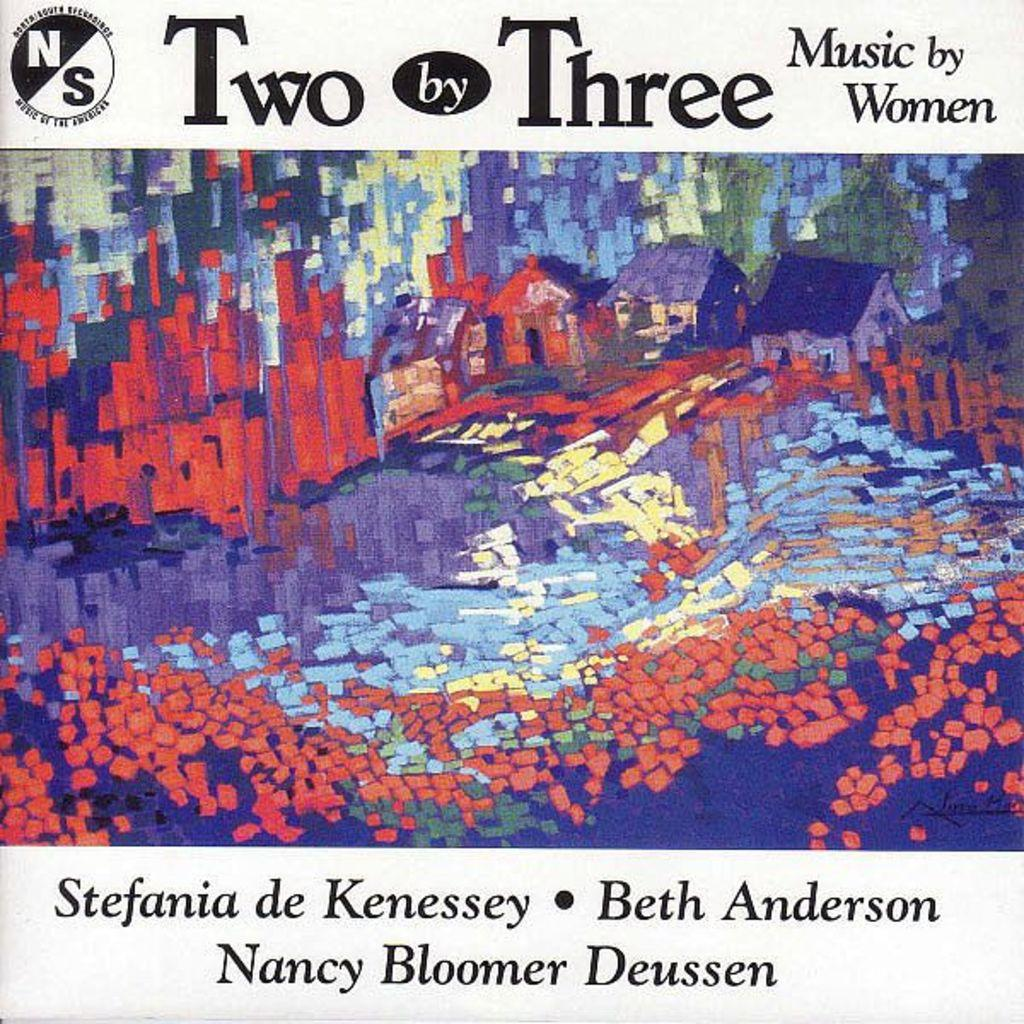<image>
Give a short and clear explanation of the subsequent image. An album cover for two by three music by women. 